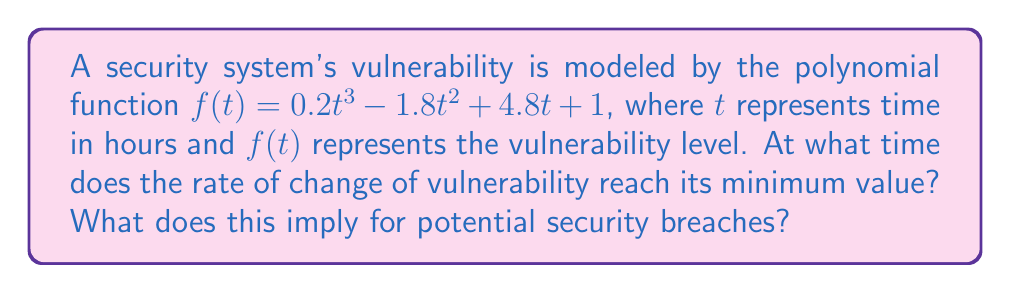Give your solution to this math problem. To solve this problem, we need to follow these steps:

1) The rate of change is represented by the first derivative of $f(t)$. Let's call this $f'(t)$:

   $f'(t) = 0.6t^2 - 3.6t + 4.8$

2) To find when the rate of change reaches its minimum, we need to find the minimum point of $f'(t)$. This occurs where the second derivative $f''(t)$ equals zero:

   $f''(t) = 1.2t - 3.6$

3) Set $f''(t) = 0$ and solve for $t$:

   $1.2t - 3.6 = 0$
   $1.2t = 3.6$
   $t = 3$

4) To confirm this is a minimum (not a maximum), we can check that $f'''(t)$ is positive:

   $f'''(t) = 1.2 > 0$

5) Therefore, the rate of change reaches its minimum at $t = 3$ hours.

This implies that at 3 hours, the vulnerability level is increasing at its slowest rate. After this point, the rate of increase in vulnerability accelerates, potentially leading to a higher risk of security breaches. Thus, this point represents a critical time for implementing additional security measures.
Answer: 3 hours 